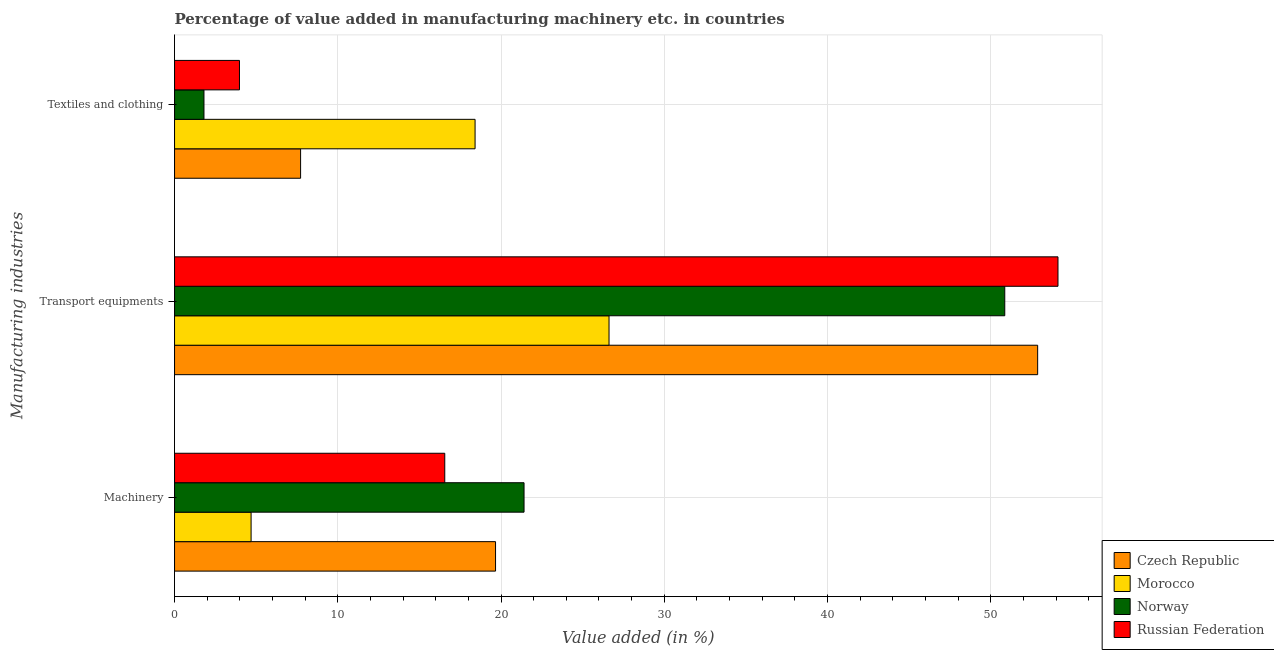How many groups of bars are there?
Offer a very short reply. 3. Are the number of bars per tick equal to the number of legend labels?
Your answer should be very brief. Yes. Are the number of bars on each tick of the Y-axis equal?
Offer a very short reply. Yes. How many bars are there on the 2nd tick from the top?
Make the answer very short. 4. What is the label of the 2nd group of bars from the top?
Keep it short and to the point. Transport equipments. What is the value added in manufacturing transport equipments in Norway?
Ensure brevity in your answer.  50.86. Across all countries, what is the maximum value added in manufacturing textile and clothing?
Provide a short and direct response. 18.41. Across all countries, what is the minimum value added in manufacturing machinery?
Provide a succinct answer. 4.69. In which country was the value added in manufacturing textile and clothing maximum?
Ensure brevity in your answer.  Morocco. In which country was the value added in manufacturing machinery minimum?
Keep it short and to the point. Morocco. What is the total value added in manufacturing transport equipments in the graph?
Your answer should be very brief. 184.46. What is the difference between the value added in manufacturing machinery in Norway and that in Czech Republic?
Your response must be concise. 1.75. What is the difference between the value added in manufacturing machinery in Czech Republic and the value added in manufacturing textile and clothing in Norway?
Offer a terse response. 17.86. What is the average value added in manufacturing textile and clothing per country?
Your answer should be compact. 7.98. What is the difference between the value added in manufacturing textile and clothing and value added in manufacturing transport equipments in Russian Federation?
Your answer should be compact. -50.14. What is the ratio of the value added in manufacturing machinery in Russian Federation to that in Norway?
Give a very brief answer. 0.77. Is the value added in manufacturing transport equipments in Morocco less than that in Czech Republic?
Your response must be concise. Yes. Is the difference between the value added in manufacturing transport equipments in Czech Republic and Norway greater than the difference between the value added in manufacturing textile and clothing in Czech Republic and Norway?
Your answer should be very brief. No. What is the difference between the highest and the second highest value added in manufacturing machinery?
Make the answer very short. 1.75. What is the difference between the highest and the lowest value added in manufacturing transport equipments?
Your response must be concise. 27.5. In how many countries, is the value added in manufacturing textile and clothing greater than the average value added in manufacturing textile and clothing taken over all countries?
Your answer should be compact. 1. Is the sum of the value added in manufacturing transport equipments in Russian Federation and Norway greater than the maximum value added in manufacturing machinery across all countries?
Offer a very short reply. Yes. What does the 1st bar from the top in Machinery represents?
Provide a succinct answer. Russian Federation. What does the 1st bar from the bottom in Machinery represents?
Provide a succinct answer. Czech Republic. Is it the case that in every country, the sum of the value added in manufacturing machinery and value added in manufacturing transport equipments is greater than the value added in manufacturing textile and clothing?
Make the answer very short. Yes. What is the difference between two consecutive major ticks on the X-axis?
Your answer should be compact. 10. Does the graph contain any zero values?
Your response must be concise. No. How many legend labels are there?
Ensure brevity in your answer.  4. How are the legend labels stacked?
Your answer should be compact. Vertical. What is the title of the graph?
Your answer should be compact. Percentage of value added in manufacturing machinery etc. in countries. Does "Namibia" appear as one of the legend labels in the graph?
Make the answer very short. No. What is the label or title of the X-axis?
Your response must be concise. Value added (in %). What is the label or title of the Y-axis?
Ensure brevity in your answer.  Manufacturing industries. What is the Value added (in %) in Czech Republic in Machinery?
Keep it short and to the point. 19.66. What is the Value added (in %) in Morocco in Machinery?
Your answer should be very brief. 4.69. What is the Value added (in %) in Norway in Machinery?
Ensure brevity in your answer.  21.41. What is the Value added (in %) in Russian Federation in Machinery?
Provide a succinct answer. 16.55. What is the Value added (in %) in Czech Republic in Transport equipments?
Your response must be concise. 52.87. What is the Value added (in %) of Morocco in Transport equipments?
Offer a terse response. 26.62. What is the Value added (in %) of Norway in Transport equipments?
Offer a terse response. 50.86. What is the Value added (in %) in Russian Federation in Transport equipments?
Offer a very short reply. 54.12. What is the Value added (in %) of Czech Republic in Textiles and clothing?
Give a very brief answer. 7.72. What is the Value added (in %) in Morocco in Textiles and clothing?
Your answer should be very brief. 18.41. What is the Value added (in %) in Norway in Textiles and clothing?
Your response must be concise. 1.8. What is the Value added (in %) in Russian Federation in Textiles and clothing?
Keep it short and to the point. 3.98. Across all Manufacturing industries, what is the maximum Value added (in %) in Czech Republic?
Keep it short and to the point. 52.87. Across all Manufacturing industries, what is the maximum Value added (in %) of Morocco?
Provide a succinct answer. 26.62. Across all Manufacturing industries, what is the maximum Value added (in %) in Norway?
Make the answer very short. 50.86. Across all Manufacturing industries, what is the maximum Value added (in %) of Russian Federation?
Provide a succinct answer. 54.12. Across all Manufacturing industries, what is the minimum Value added (in %) of Czech Republic?
Ensure brevity in your answer.  7.72. Across all Manufacturing industries, what is the minimum Value added (in %) of Morocco?
Your answer should be very brief. 4.69. Across all Manufacturing industries, what is the minimum Value added (in %) in Norway?
Keep it short and to the point. 1.8. Across all Manufacturing industries, what is the minimum Value added (in %) of Russian Federation?
Ensure brevity in your answer.  3.98. What is the total Value added (in %) in Czech Republic in the graph?
Your response must be concise. 80.26. What is the total Value added (in %) of Morocco in the graph?
Offer a terse response. 49.71. What is the total Value added (in %) of Norway in the graph?
Offer a terse response. 74.07. What is the total Value added (in %) of Russian Federation in the graph?
Your answer should be very brief. 74.65. What is the difference between the Value added (in %) of Czech Republic in Machinery and that in Transport equipments?
Offer a terse response. -33.21. What is the difference between the Value added (in %) in Morocco in Machinery and that in Transport equipments?
Your answer should be compact. -21.93. What is the difference between the Value added (in %) in Norway in Machinery and that in Transport equipments?
Your answer should be very brief. -29.45. What is the difference between the Value added (in %) of Russian Federation in Machinery and that in Transport equipments?
Provide a short and direct response. -37.56. What is the difference between the Value added (in %) of Czech Republic in Machinery and that in Textiles and clothing?
Give a very brief answer. 11.94. What is the difference between the Value added (in %) in Morocco in Machinery and that in Textiles and clothing?
Keep it short and to the point. -13.72. What is the difference between the Value added (in %) of Norway in Machinery and that in Textiles and clothing?
Your response must be concise. 19.61. What is the difference between the Value added (in %) of Russian Federation in Machinery and that in Textiles and clothing?
Your answer should be very brief. 12.58. What is the difference between the Value added (in %) of Czech Republic in Transport equipments and that in Textiles and clothing?
Your answer should be very brief. 45.15. What is the difference between the Value added (in %) of Morocco in Transport equipments and that in Textiles and clothing?
Ensure brevity in your answer.  8.21. What is the difference between the Value added (in %) in Norway in Transport equipments and that in Textiles and clothing?
Provide a succinct answer. 49.06. What is the difference between the Value added (in %) in Russian Federation in Transport equipments and that in Textiles and clothing?
Your answer should be compact. 50.14. What is the difference between the Value added (in %) of Czech Republic in Machinery and the Value added (in %) of Morocco in Transport equipments?
Ensure brevity in your answer.  -6.95. What is the difference between the Value added (in %) in Czech Republic in Machinery and the Value added (in %) in Norway in Transport equipments?
Keep it short and to the point. -31.19. What is the difference between the Value added (in %) of Czech Republic in Machinery and the Value added (in %) of Russian Federation in Transport equipments?
Provide a short and direct response. -34.45. What is the difference between the Value added (in %) in Morocco in Machinery and the Value added (in %) in Norway in Transport equipments?
Your answer should be very brief. -46.17. What is the difference between the Value added (in %) in Morocco in Machinery and the Value added (in %) in Russian Federation in Transport equipments?
Provide a succinct answer. -49.43. What is the difference between the Value added (in %) of Norway in Machinery and the Value added (in %) of Russian Federation in Transport equipments?
Your answer should be compact. -32.71. What is the difference between the Value added (in %) of Czech Republic in Machinery and the Value added (in %) of Morocco in Textiles and clothing?
Offer a very short reply. 1.25. What is the difference between the Value added (in %) of Czech Republic in Machinery and the Value added (in %) of Norway in Textiles and clothing?
Make the answer very short. 17.86. What is the difference between the Value added (in %) in Czech Republic in Machinery and the Value added (in %) in Russian Federation in Textiles and clothing?
Your answer should be compact. 15.69. What is the difference between the Value added (in %) of Morocco in Machinery and the Value added (in %) of Norway in Textiles and clothing?
Offer a terse response. 2.89. What is the difference between the Value added (in %) of Morocco in Machinery and the Value added (in %) of Russian Federation in Textiles and clothing?
Give a very brief answer. 0.71. What is the difference between the Value added (in %) of Norway in Machinery and the Value added (in %) of Russian Federation in Textiles and clothing?
Make the answer very short. 17.43. What is the difference between the Value added (in %) in Czech Republic in Transport equipments and the Value added (in %) in Morocco in Textiles and clothing?
Your response must be concise. 34.46. What is the difference between the Value added (in %) in Czech Republic in Transport equipments and the Value added (in %) in Norway in Textiles and clothing?
Your answer should be very brief. 51.07. What is the difference between the Value added (in %) of Czech Republic in Transport equipments and the Value added (in %) of Russian Federation in Textiles and clothing?
Provide a succinct answer. 48.9. What is the difference between the Value added (in %) of Morocco in Transport equipments and the Value added (in %) of Norway in Textiles and clothing?
Provide a succinct answer. 24.81. What is the difference between the Value added (in %) in Morocco in Transport equipments and the Value added (in %) in Russian Federation in Textiles and clothing?
Keep it short and to the point. 22.64. What is the difference between the Value added (in %) of Norway in Transport equipments and the Value added (in %) of Russian Federation in Textiles and clothing?
Give a very brief answer. 46.88. What is the average Value added (in %) of Czech Republic per Manufacturing industries?
Make the answer very short. 26.75. What is the average Value added (in %) of Morocco per Manufacturing industries?
Your response must be concise. 16.57. What is the average Value added (in %) in Norway per Manufacturing industries?
Keep it short and to the point. 24.69. What is the average Value added (in %) in Russian Federation per Manufacturing industries?
Give a very brief answer. 24.88. What is the difference between the Value added (in %) in Czech Republic and Value added (in %) in Morocco in Machinery?
Offer a terse response. 14.97. What is the difference between the Value added (in %) in Czech Republic and Value added (in %) in Norway in Machinery?
Provide a short and direct response. -1.75. What is the difference between the Value added (in %) in Czech Republic and Value added (in %) in Russian Federation in Machinery?
Your answer should be compact. 3.11. What is the difference between the Value added (in %) in Morocco and Value added (in %) in Norway in Machinery?
Your answer should be compact. -16.72. What is the difference between the Value added (in %) of Morocco and Value added (in %) of Russian Federation in Machinery?
Provide a short and direct response. -11.86. What is the difference between the Value added (in %) of Norway and Value added (in %) of Russian Federation in Machinery?
Your answer should be compact. 4.86. What is the difference between the Value added (in %) of Czech Republic and Value added (in %) of Morocco in Transport equipments?
Your answer should be compact. 26.26. What is the difference between the Value added (in %) of Czech Republic and Value added (in %) of Norway in Transport equipments?
Give a very brief answer. 2.01. What is the difference between the Value added (in %) of Czech Republic and Value added (in %) of Russian Federation in Transport equipments?
Offer a very short reply. -1.25. What is the difference between the Value added (in %) of Morocco and Value added (in %) of Norway in Transport equipments?
Your response must be concise. -24.24. What is the difference between the Value added (in %) of Morocco and Value added (in %) of Russian Federation in Transport equipments?
Provide a succinct answer. -27.5. What is the difference between the Value added (in %) of Norway and Value added (in %) of Russian Federation in Transport equipments?
Give a very brief answer. -3.26. What is the difference between the Value added (in %) of Czech Republic and Value added (in %) of Morocco in Textiles and clothing?
Give a very brief answer. -10.69. What is the difference between the Value added (in %) in Czech Republic and Value added (in %) in Norway in Textiles and clothing?
Your response must be concise. 5.92. What is the difference between the Value added (in %) in Czech Republic and Value added (in %) in Russian Federation in Textiles and clothing?
Offer a very short reply. 3.75. What is the difference between the Value added (in %) of Morocco and Value added (in %) of Norway in Textiles and clothing?
Offer a very short reply. 16.61. What is the difference between the Value added (in %) in Morocco and Value added (in %) in Russian Federation in Textiles and clothing?
Make the answer very short. 14.43. What is the difference between the Value added (in %) in Norway and Value added (in %) in Russian Federation in Textiles and clothing?
Give a very brief answer. -2.17. What is the ratio of the Value added (in %) of Czech Republic in Machinery to that in Transport equipments?
Provide a short and direct response. 0.37. What is the ratio of the Value added (in %) in Morocco in Machinery to that in Transport equipments?
Provide a short and direct response. 0.18. What is the ratio of the Value added (in %) in Norway in Machinery to that in Transport equipments?
Your response must be concise. 0.42. What is the ratio of the Value added (in %) in Russian Federation in Machinery to that in Transport equipments?
Your answer should be compact. 0.31. What is the ratio of the Value added (in %) of Czech Republic in Machinery to that in Textiles and clothing?
Offer a very short reply. 2.55. What is the ratio of the Value added (in %) in Morocco in Machinery to that in Textiles and clothing?
Offer a terse response. 0.25. What is the ratio of the Value added (in %) of Norway in Machinery to that in Textiles and clothing?
Your answer should be very brief. 11.88. What is the ratio of the Value added (in %) of Russian Federation in Machinery to that in Textiles and clothing?
Keep it short and to the point. 4.16. What is the ratio of the Value added (in %) in Czech Republic in Transport equipments to that in Textiles and clothing?
Keep it short and to the point. 6.85. What is the ratio of the Value added (in %) of Morocco in Transport equipments to that in Textiles and clothing?
Offer a terse response. 1.45. What is the ratio of the Value added (in %) of Norway in Transport equipments to that in Textiles and clothing?
Your response must be concise. 28.22. What is the ratio of the Value added (in %) in Russian Federation in Transport equipments to that in Textiles and clothing?
Ensure brevity in your answer.  13.61. What is the difference between the highest and the second highest Value added (in %) of Czech Republic?
Your answer should be very brief. 33.21. What is the difference between the highest and the second highest Value added (in %) in Morocco?
Your response must be concise. 8.21. What is the difference between the highest and the second highest Value added (in %) in Norway?
Give a very brief answer. 29.45. What is the difference between the highest and the second highest Value added (in %) of Russian Federation?
Ensure brevity in your answer.  37.56. What is the difference between the highest and the lowest Value added (in %) in Czech Republic?
Ensure brevity in your answer.  45.15. What is the difference between the highest and the lowest Value added (in %) in Morocco?
Make the answer very short. 21.93. What is the difference between the highest and the lowest Value added (in %) of Norway?
Give a very brief answer. 49.06. What is the difference between the highest and the lowest Value added (in %) in Russian Federation?
Provide a succinct answer. 50.14. 